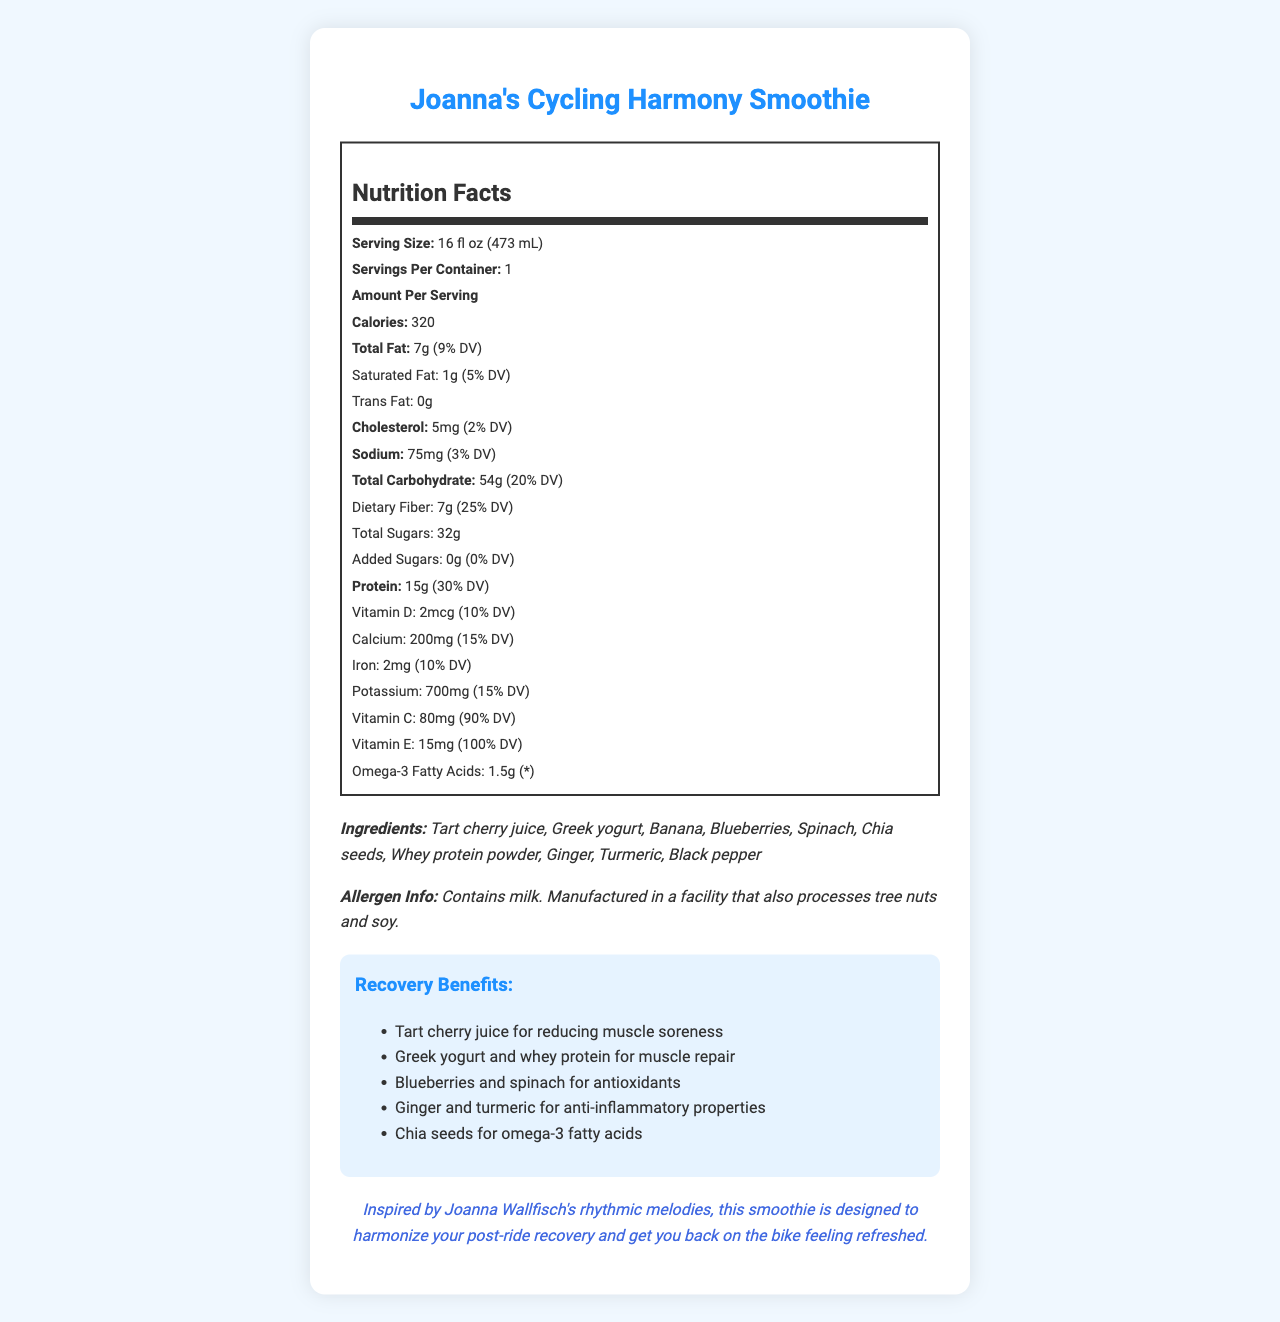what is the serving size? The serving size is listed under "Serving Size" in the nutrition facts section of the document.
Answer: 16 fl oz (473 mL) how many calories are in one serving? The number of calories per serving is stated directly in the nutrition facts under "Amount Per Serving."
Answer: 320 what are the recovery benefits of this smoothie? The recovery benefits are listed in a dedicated section titled "Recovery Benefits."
Answer: Reducing muscle soreness, muscle repair, antioxidants, anti-inflammatory properties, omega-3 fatty acids how much protein does this smoothie contain? The protein content is listed in the nutrition facts under "Amount Per Serving."
Answer: 15g what allergens are present in this product? The allergen information is provided under the "Ingredients" section.
Answer: Contains milk. Manufactured in a facility that also processes tree nuts and soy. how much dietary fiber is in one serving? The dietary fiber content is listed under "Dietary Fiber" in the nutrition facts section.
Answer: 7g what is the serving size of Joanna's Cycling Harmony Smoothie? A. 12 fl oz B. 16 fl oz C. 20 fl oz The serving size is 16 fl oz (473 mL), which is stated under the serving size section in the nutrition facts.
Answer: B which ingredient helps with reducing muscle soreness? i. Ginger ii. Tart cherry juice iii. Black pepper iv. Blueberries Tart cherry juice is mentioned as an ingredient that helps with reducing muscle soreness in the recovery benefits section.
Answer: ii does this smoothie contain any added sugars? The document states there are 0 grams of added sugars.
Answer: No is the smoothie inspired by Joanna Wallfisch’s music? The cycling performance note mentions that the smoothie is inspired by Joanna Wallfisch's rhythmic melodies.
Answer: Yes summarize the main idea of this document. The document provides detailed information on the nutritional content, ingredients, allergen information, and recovery benefits of Joanna's Cycling Harmony Smoothie, highlighting its specific purpose for post-ride recovery and its inspiration from Joanna Wallfisch's music.
Answer: Joanna's Cycling Harmony Smoothie is designed specifically for post-ride recovery, featuring a comprehensive nutrition profile and beneficial ingredients aimed at reducing muscle soreness, repairing muscles, providing antioxidants, and offering anti-inflammatory properties. It includes tart cherry juice, Greek yogurt, banana, blueberries, spinach, chia seeds, whey protein powder, ginger, turmeric, and black pepper. The product is inspired by Joanna Wallfisch’s music and aims to harmonize recovery for cyclists. how much potassium is in this smoothie? The amount of potassium is listed under "Potassium" in the nutrition facts section.
Answer: 700mg which of these vitamins has the highest daily value percentage in the smoothie? A. Vitamin D B. Vitamin C C. Vitamin E D. Vitamin A Vitamin E has the highest daily value percentage at 100% DV, as stated in the nutrition facts.
Answer: C can I find the exact price of the smoothie in this document? The document does not provide any information regarding the price of the smoothie.
Answer: Not enough information 